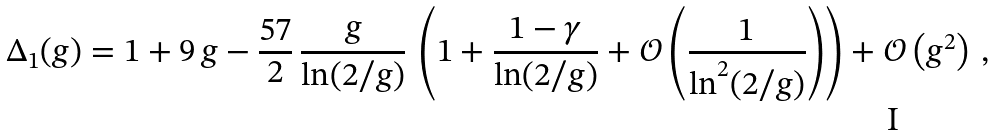<formula> <loc_0><loc_0><loc_500><loc_500>\Delta _ { 1 } ( g ) = 1 + 9 \, g - \frac { 5 7 } { 2 } \, \frac { g } { \ln ( 2 / g ) } \, \left ( 1 + \frac { 1 - \gamma } { \ln ( 2 / g ) } + { \mathcal { O } } \left ( \frac { 1 } { \ln ^ { 2 } ( 2 / g ) } \right ) \right ) + { \mathcal { O } } \left ( g ^ { 2 } \right ) \, ,</formula> 